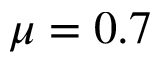Convert formula to latex. <formula><loc_0><loc_0><loc_500><loc_500>\mu = 0 . 7</formula> 